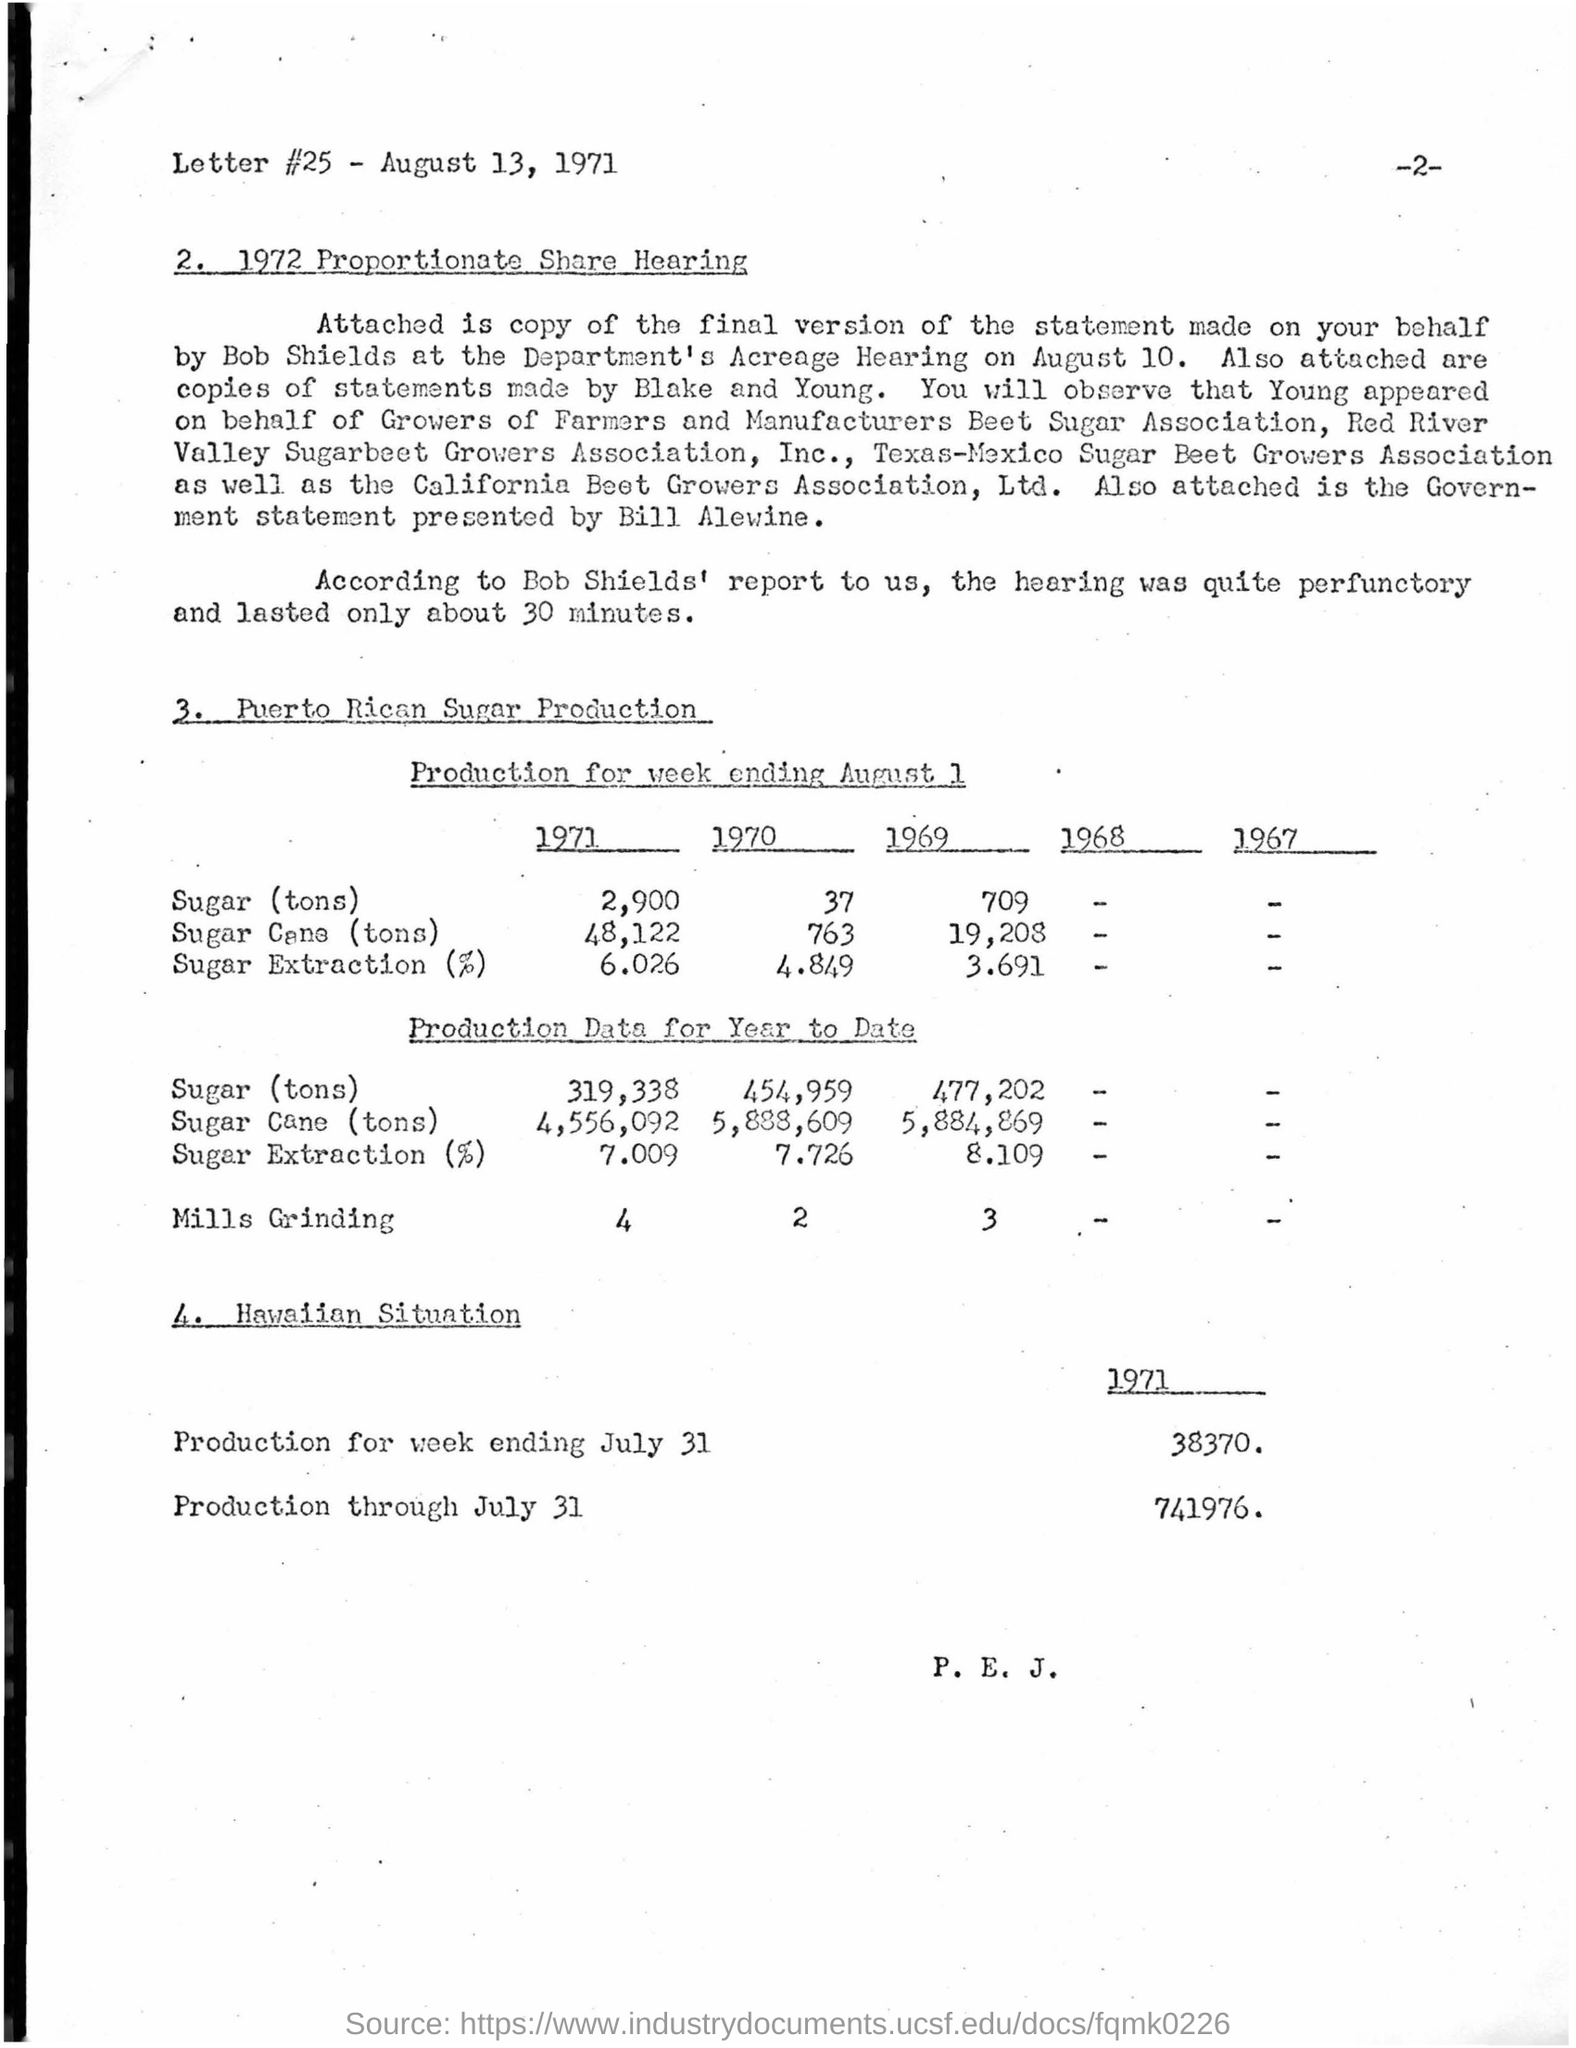What is the Letter #25 date mentioned?
Keep it short and to the point. August 13,  1971. "Proportionate Share Hearing" of which year is given"?
Your answer should be compact. 1972. Who has made the "final version of the statement"?
Your answer should be compact. Bob Shields. "Copies of statements" are made by whom?
Offer a terse response. Blake and  Young. How long did the hearing last according to Bob Shields' report?
Your answer should be compact. 30 minutes. What is the quantity of "Sugar(tons)" produced in the year 1971 mentioned under the heading "Production for week ending August 1 " ?
Ensure brevity in your answer.  2,900. What is the quantity of "Sugar Extraction(%)" produced in the year 1970 mentioned under the heading "Production for week ending August 1 " ?
Keep it short and to the point. 4.849. What is the "Production for week ending JULY 31"  in the year 1971 under "Hawaiian Situation"?
Give a very brief answer. 38370. What is the "Production Data for Year to Date" for "Mills Grinding" in the year 1971?
Provide a short and direct response. 4. What is the "Production Data for Year to Date" for "Sugar Cane(tons) in the year 1970?
Provide a succinct answer. 5,888,609. 